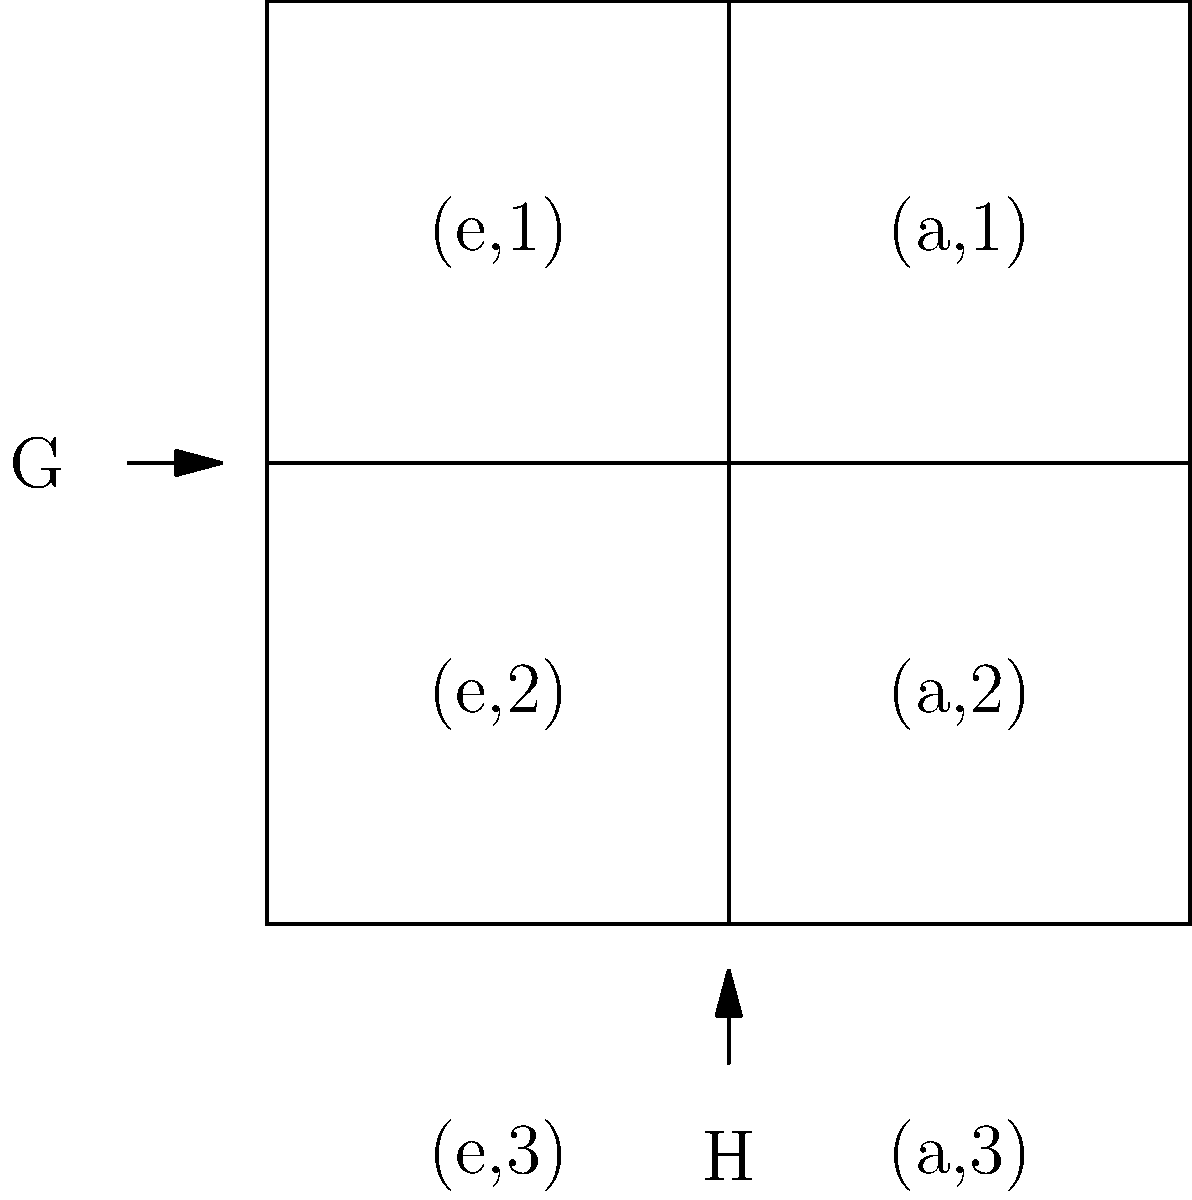In the context of ensuring compliance with regulatory standards for software solutions, consider the direct product of two groups $G = \{e, a\}$ and $H = \{1, 2, 3\}$. How many elements are in the resulting group $G \times H$, and what implications might this have for data classification and access control policies? To determine the number of elements in the direct product $G \times H$ and understand its implications for compliance:

1. Identify the elements of each group:
   Group $G = \{e, a\}$ has 2 elements
   Group $H = \{1, 2, 3\}$ has 3 elements

2. Understand the direct product operation:
   $G \times H = \{(g, h) | g \in G, h \in H\}$

3. Count the elements in $G \times H$:
   Each element of $G$ is paired with each element of $H$
   Total elements = $|G| \times |H| = 2 \times 3 = 6$

4. List all elements of $G \times H$:
   $\{(e,1), (e,2), (e,3), (a,1), (a,2), (a,3)\}$

5. Implications for compliance:
   a. Data Classification: The 6 elements could represent different levels of data sensitivity or access permissions.
   b. Access Control: Each pair could define a unique combination of user role (from $G$) and data category (from $H$).
   c. Audit Trails: The structure allows for precise tracking of actions based on role-category combinations.
   d. Policy Enforcement: Policies can be defined granularly for each element in the direct product.

6. Regulatory Considerations:
   a. The structure aligns with the principle of least privilege by allowing fine-grained access control.
   b. It supports data segregation requirements often mandated in financial or healthcare regulations.
   c. The clear structure aids in demonstrating compliance during audits.
Answer: 6 elements; enables fine-grained access control and data classification 